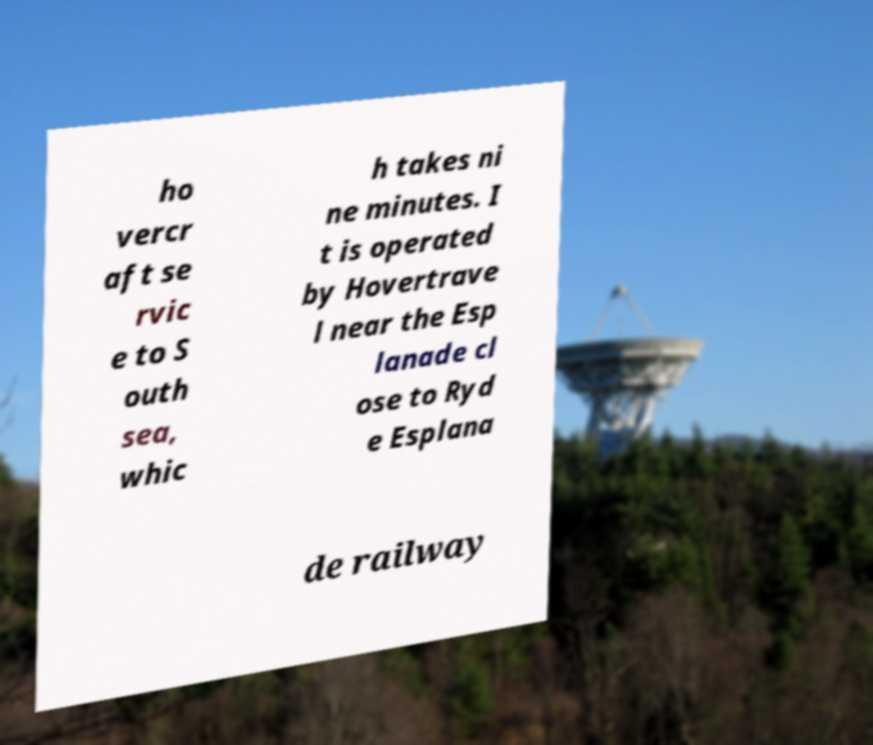For documentation purposes, I need the text within this image transcribed. Could you provide that? ho vercr aft se rvic e to S outh sea, whic h takes ni ne minutes. I t is operated by Hovertrave l near the Esp lanade cl ose to Ryd e Esplana de railway 